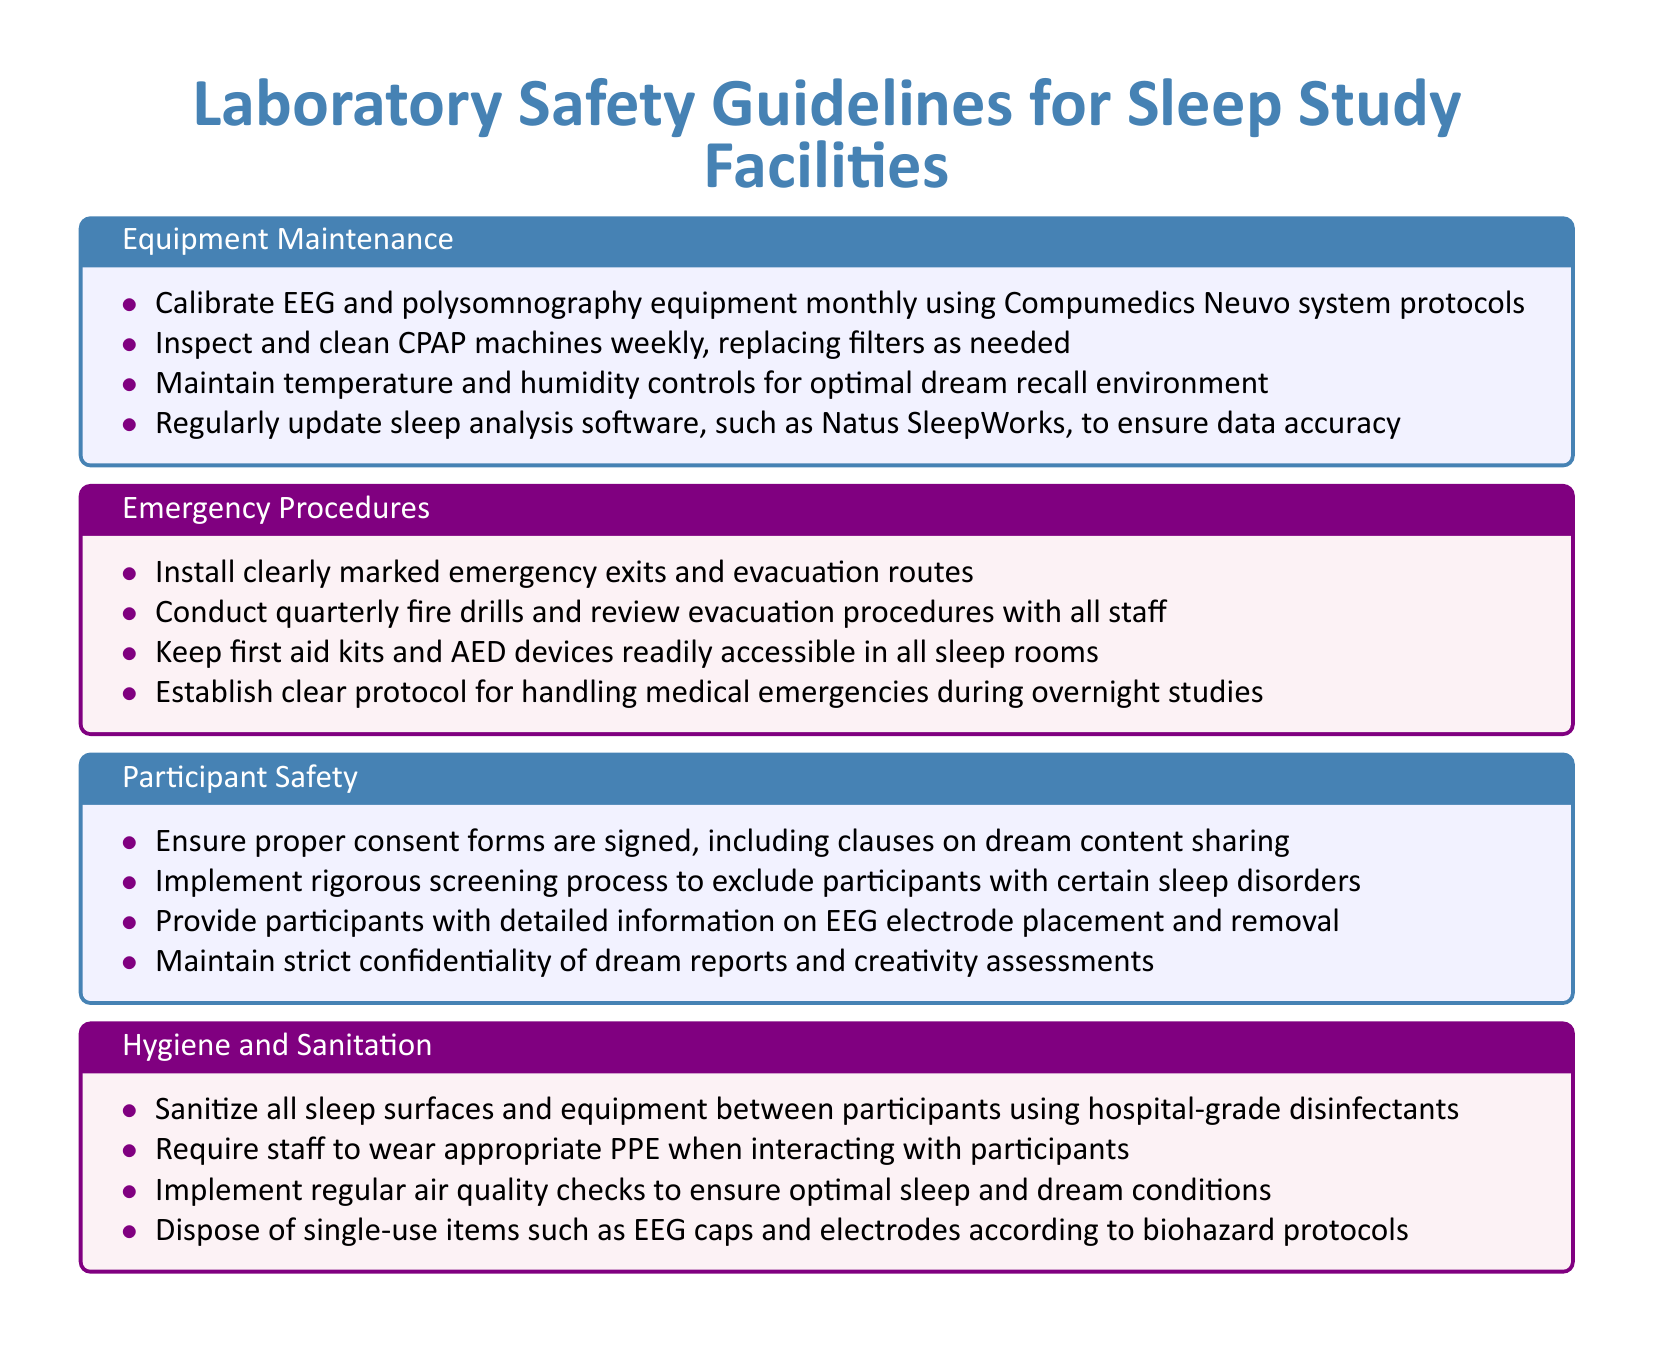What is the monthly maintenance protocol for EEG equipment? The guideline specifies a calibration of EEG equipment monthly using Compumedics Neuvo system protocols.
Answer: Calibrate EEG equipment monthly How often should CPAP machines be cleaned? The document states that CPAP machines should be inspected and cleaned weekly.
Answer: Weekly What should be readily accessible in all sleep rooms? According to the emergency procedures, first aid kits and AED devices should be easily accessible in all sleep rooms.
Answer: First aid kits and AED devices How often are fire drills conducted? The policy document indicates that fire drills should be conducted quarterly.
Answer: Quarterly What is required from participants before studies? Participants need to sign proper consent forms that include clauses on dream content sharing.
Answer: Consent forms What is one aspect to ensure participant confidentiality? The document emphasizes maintaining confidentiality of dream reports and creativity assessments.
Answer: Confidentiality of dream reports What cleaning protocol is specified for sleep surfaces? The guidelines dictate to sanitize all sleep surfaces and equipment between participants using hospital-grade disinfectants.
Answer: Sanitize surfaces between participants What type of protective equipment must staff wear? Staff are required to wear appropriate personal protective equipment (PPE) when interacting with participants.
Answer: Personal protective equipment (PPE) What should be done with single-use items? The guidelines instruct to dispose of single-use items such as EEG caps and electrodes according to biohazard protocols.
Answer: Dispose according to biohazard protocols 